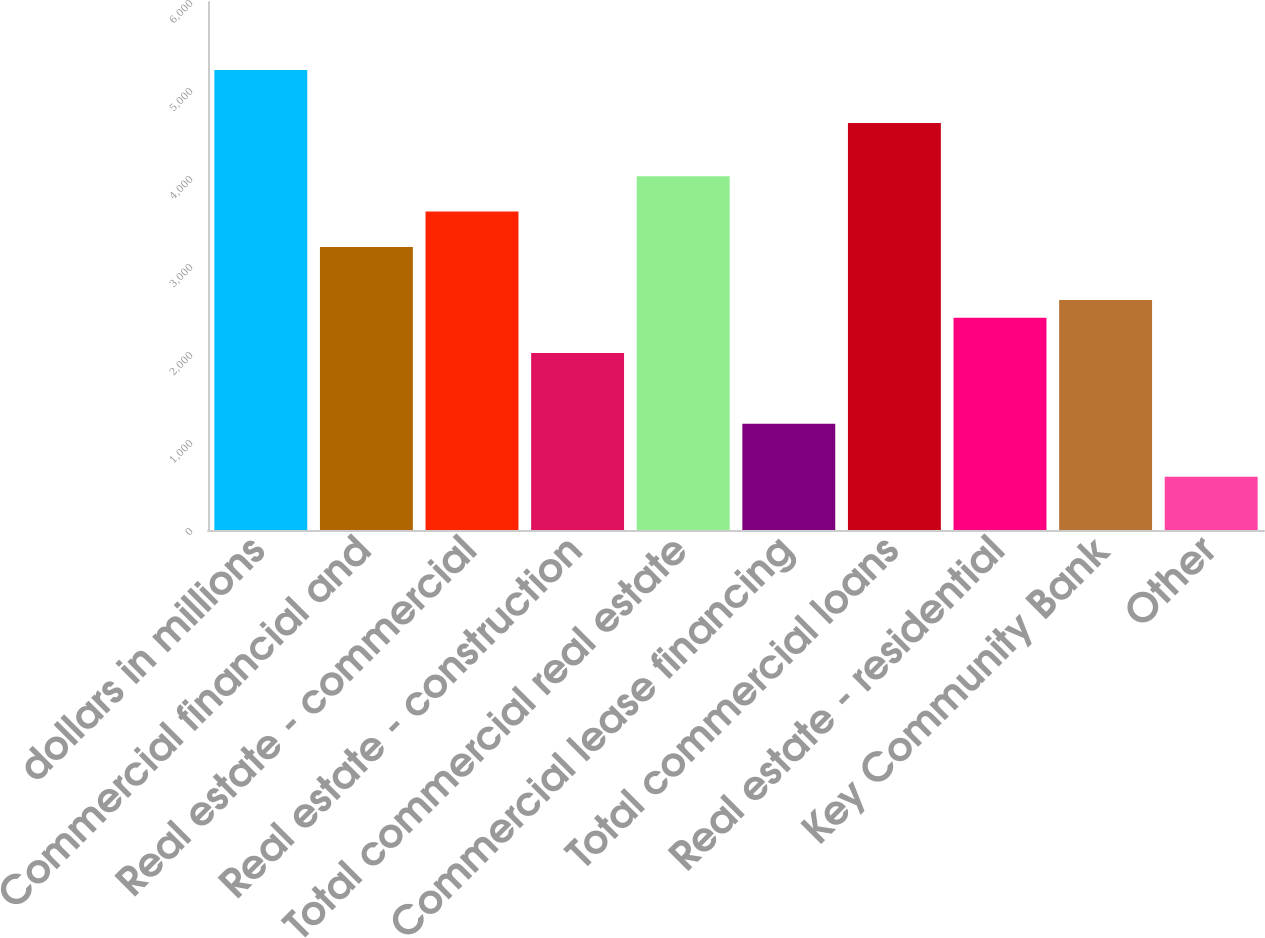Convert chart. <chart><loc_0><loc_0><loc_500><loc_500><bar_chart><fcel>dollars in millions<fcel>Commercial financial and<fcel>Real estate - commercial<fcel>Real estate - construction<fcel>Total commercial real estate<fcel>Commercial lease financing<fcel>Total commercial loans<fcel>Real estate - residential<fcel>Key Community Bank<fcel>Other<nl><fcel>5227<fcel>3217<fcel>3619<fcel>2011<fcel>4021<fcel>1207<fcel>4624<fcel>2413<fcel>2614<fcel>604<nl></chart> 